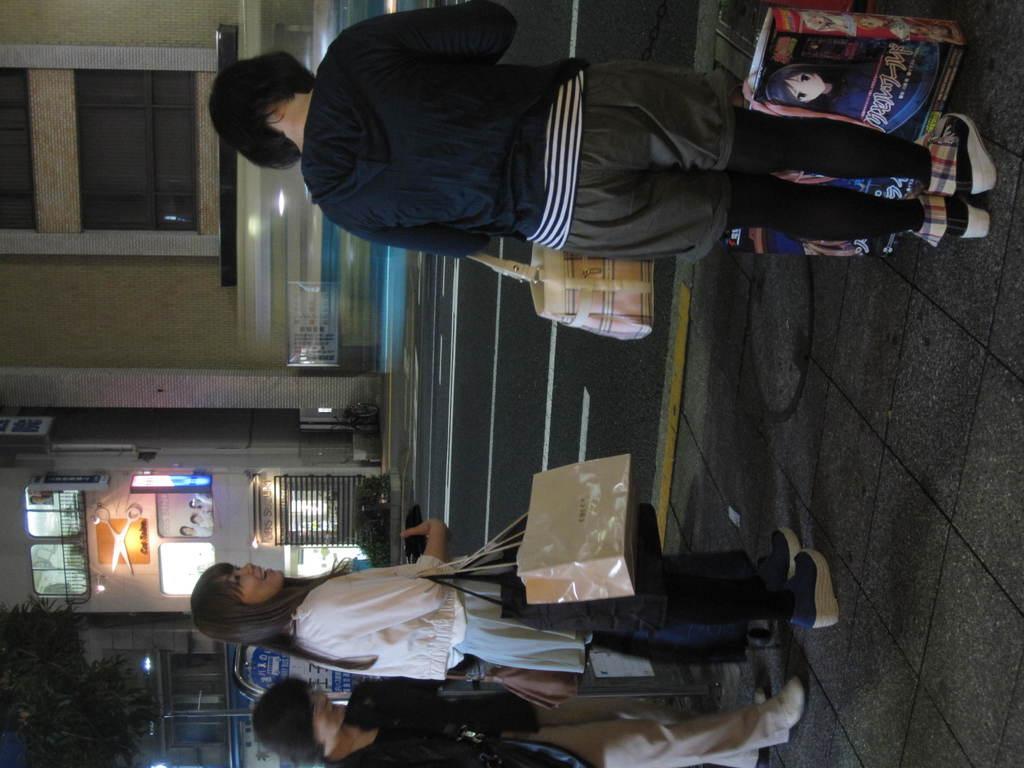In one or two sentences, can you explain what this image depicts? In the picture I can see three women standing on the side of the road and they are holding the bags. I can see the buildings on the side of the road. There is a tree on the bottom left side of the picture. 